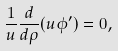<formula> <loc_0><loc_0><loc_500><loc_500>\frac { 1 } { u } \frac { d } { d \rho } ( u \phi ^ { \prime } ) = 0 ,</formula> 